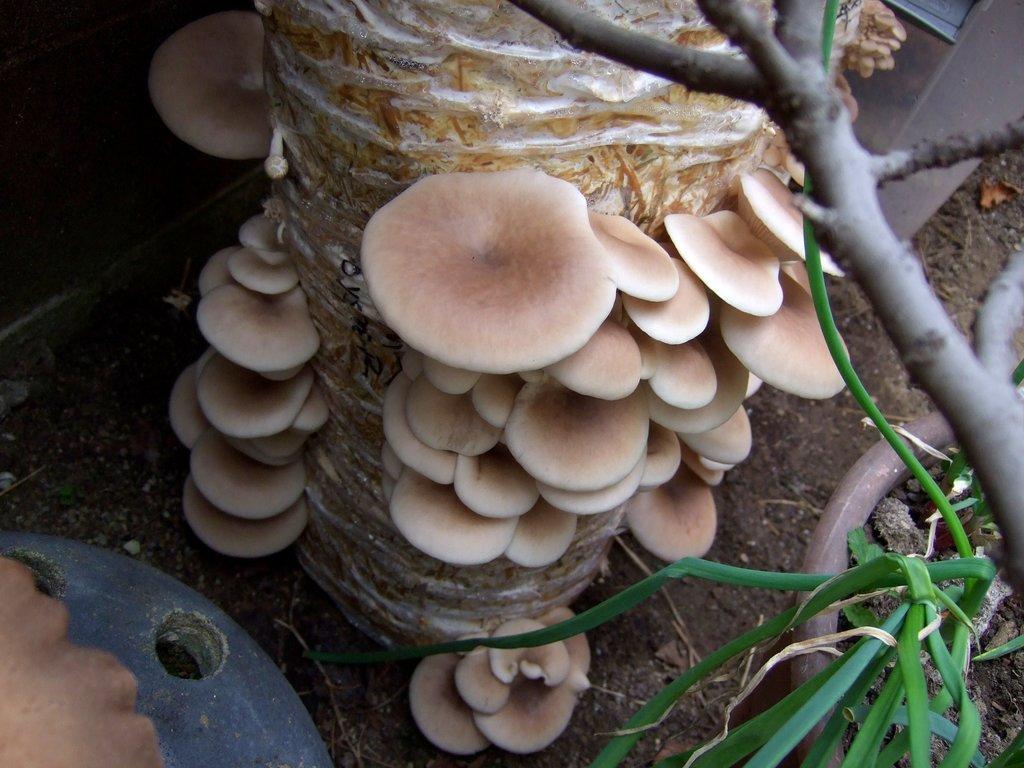How would you summarize this image in a sentence or two? In this image I can see a fungus which is cream color and I can see plants in green color. 